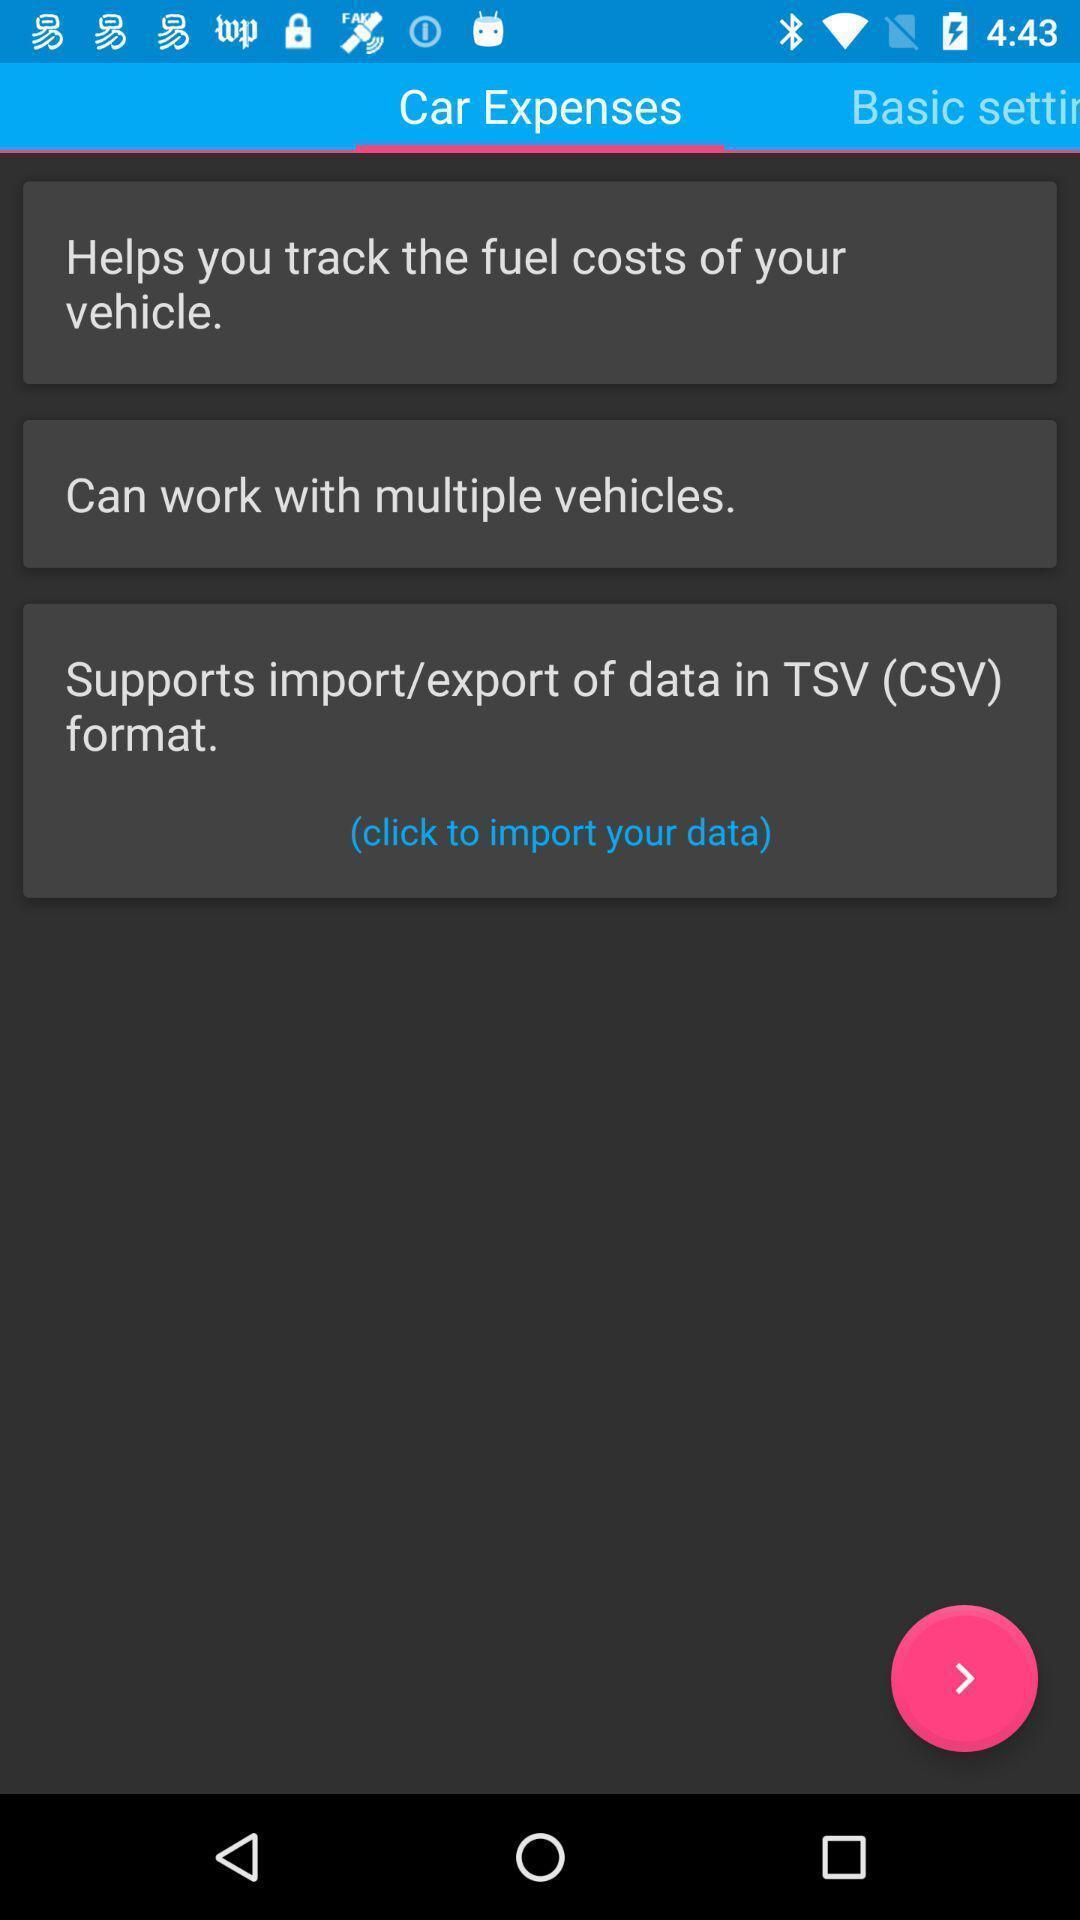Tell me about the visual elements in this screen capture. Screen shows a list of car expenses. 